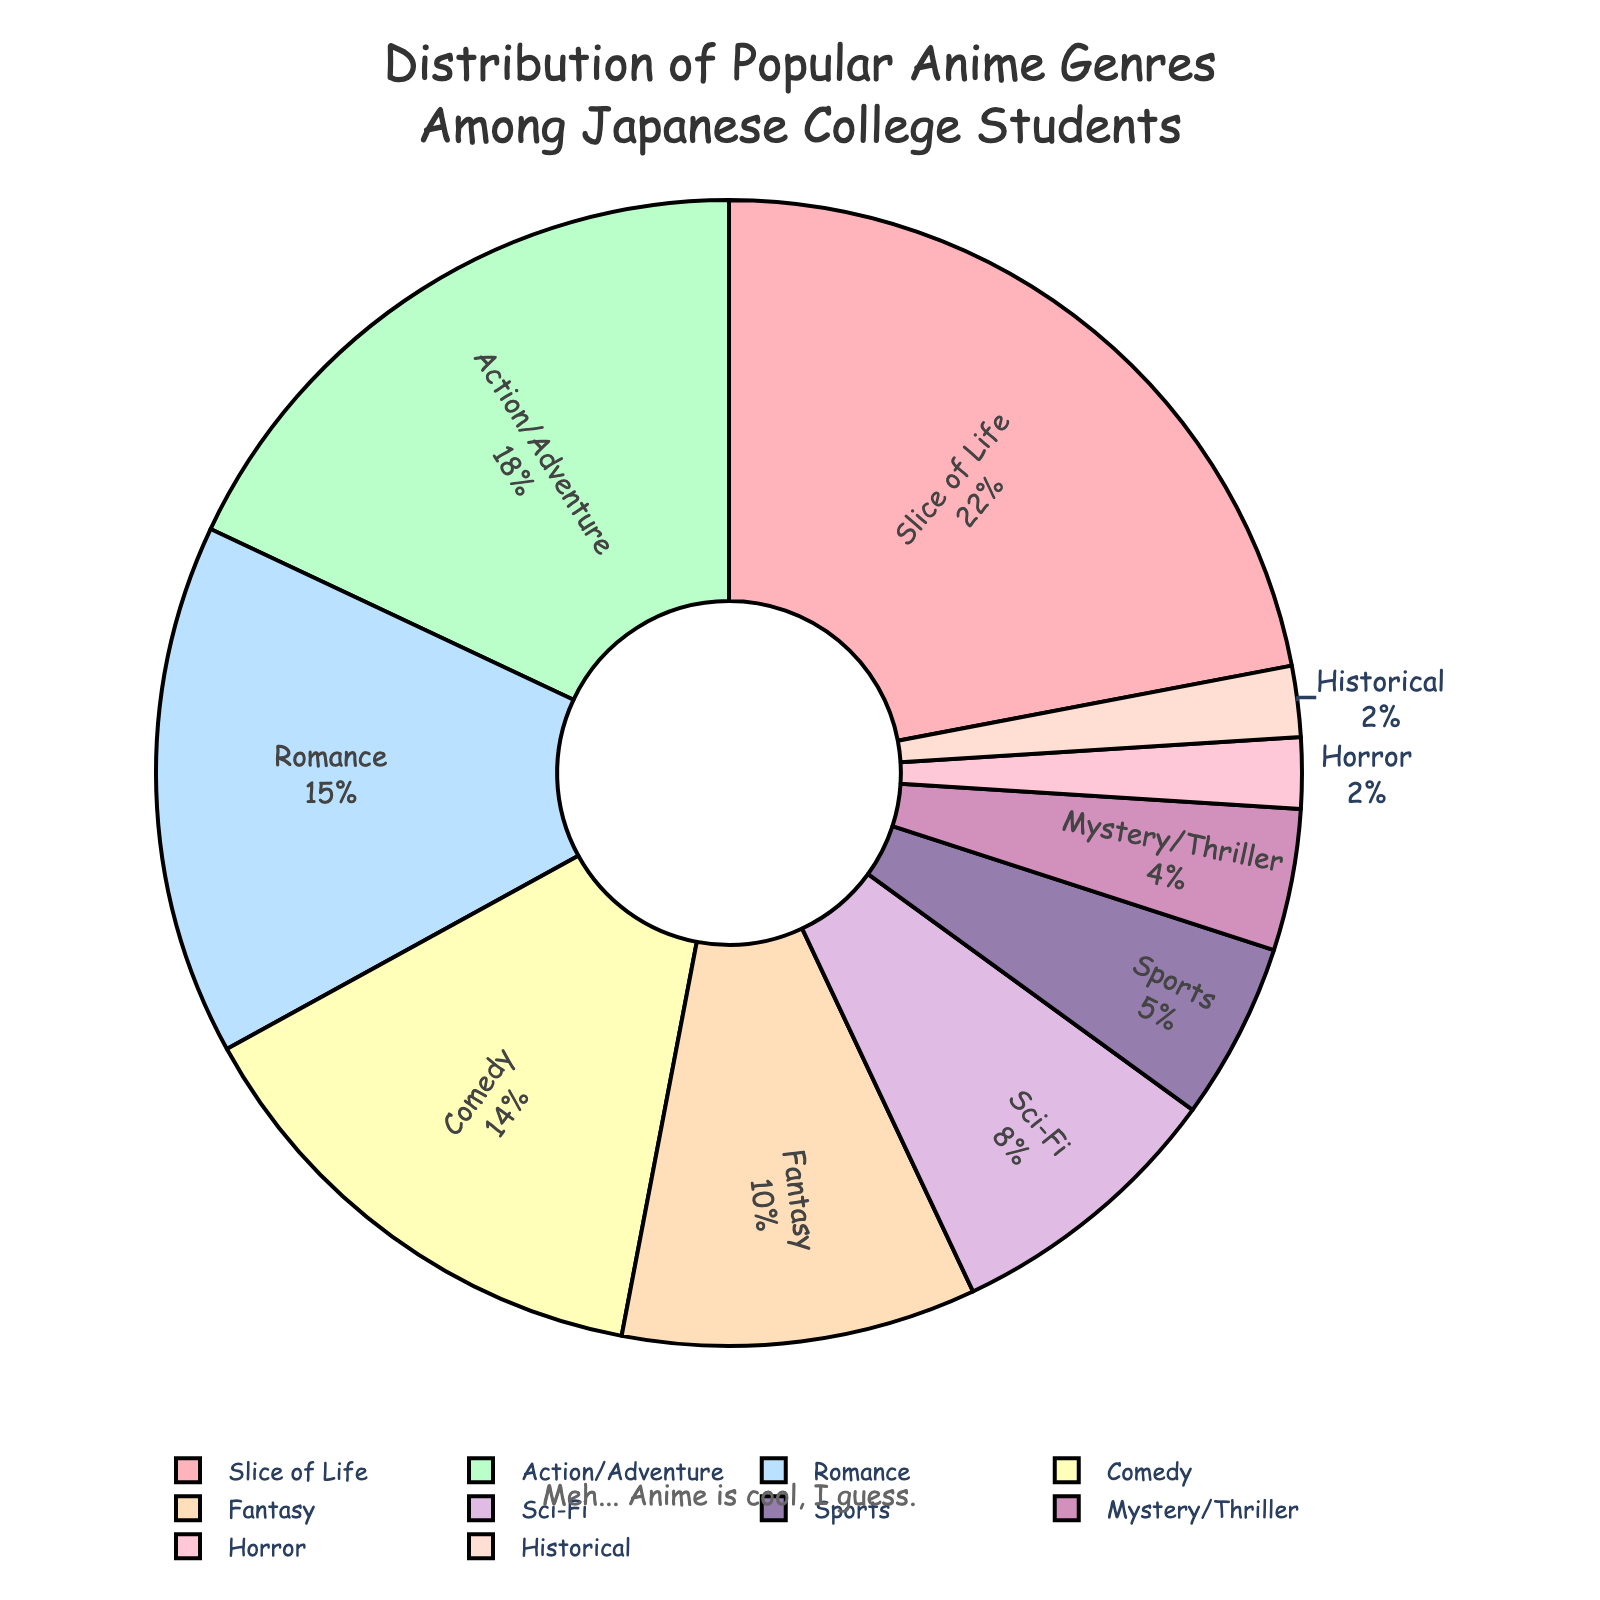what's the most popular anime genre? The largest segment in the pie chart shows Slice of Life is the most popular anime genre among Japanese college students, with 22%.
Answer: Slice of Life how does the popularity of Action/Adventure compare to Romance? By looking at the pie chart, Action/Adventure occupies 18% of the total, while Romance occupies 15%. Comparing these percentages, Action/Adventure is more popular than Romance.
Answer: Action/Adventure is more popular which genre has the least popularity and what percentage does it hold? The smallest segments of the pie chart are Horror and Historical, each holding 2% of the total, making them the least popular genres.
Answer: Horror and Historical, 2% how many genres constitute more than 10% of the preferences? Looking at the pie chart, the genres with percentages more than 10% are Slice of Life (22%), Action/Adventure (18%), Romance (15%), and Comedy (14%). Counting these, there are 4 genres.
Answer: 4 what is the combined popularity percentage of Fantasy and Sci-Fi? The percentage for Fantasy is 10%, and for Sci-Fi it is 8%. Adding them together, the combined percentage is 10% + 8% = 18%.
Answer: 18% is Comedy more popular than Fantasy and Sci-Fi combined? Comedy holds 14% of the total, while Fantasy and Sci-Fi combined hold 18%. Therefore, Comedy is less popular than the combined percentage of Fantasy and Sci-Fi.
Answer: No what is the popularity difference between Sports and Mystery/Thriller genres? The percentage for Sports is 5%, and for Mystery/Thriller, it is 4%. The difference between them is 5% - 4% = 1%.
Answer: 1% in terms of visual size, which genre has a larger segment: Sci-Fi or Sports? By observing the pie chart, Sci-Fi holds 8%, whereas Sports occupies 5%. The Sci-Fi segment is visibly larger than the Sports segment.
Answer: Sci-Fi what color is the segment representing Comedy? The segment representing Comedy is identified by its color, which is displayed as a shade consistent with the color scheme used. By confirming visually, it is the yellowish segment.
Answer: Yellowish compositional question: what is the total percentage of genres with less than 10% popularity? Genres less than 10% are Sci-Fi (8%), Sports (5%), Mystery/Thriller (4%), Horror (2%), and Historical (2%). Summing them gives 8% + 5% + 4% + 2% + 2% = 21%.
Answer: 21% 